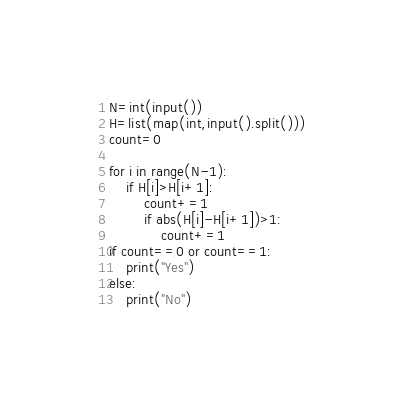Convert code to text. <code><loc_0><loc_0><loc_500><loc_500><_Python_>N=int(input())
H=list(map(int,input().split()))
count=0

for i in range(N-1):
    if H[i]>H[i+1]:
        count+=1
        if abs(H[i]-H[i+1])>1:
            count+=1
if count==0 or count==1:
    print("Yes")
else:
    print("No")
</code> 